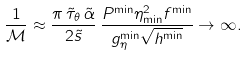Convert formula to latex. <formula><loc_0><loc_0><loc_500><loc_500>\frac { 1 } { \mathcal { M } } \approx \frac { \pi \, \tilde { \tau } _ { \theta } \, \tilde { \alpha } } { 2 \tilde { s } } \, \frac { P ^ { \min } \eta _ { \min } ^ { 2 } f ^ { \min } } { g _ { \eta } ^ { \min } \sqrt { h ^ { \min } } } \rightarrow \infty .</formula> 